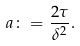Convert formula to latex. <formula><loc_0><loc_0><loc_500><loc_500>a \colon = \frac { 2 \tau } { \delta ^ { 2 } } .</formula> 